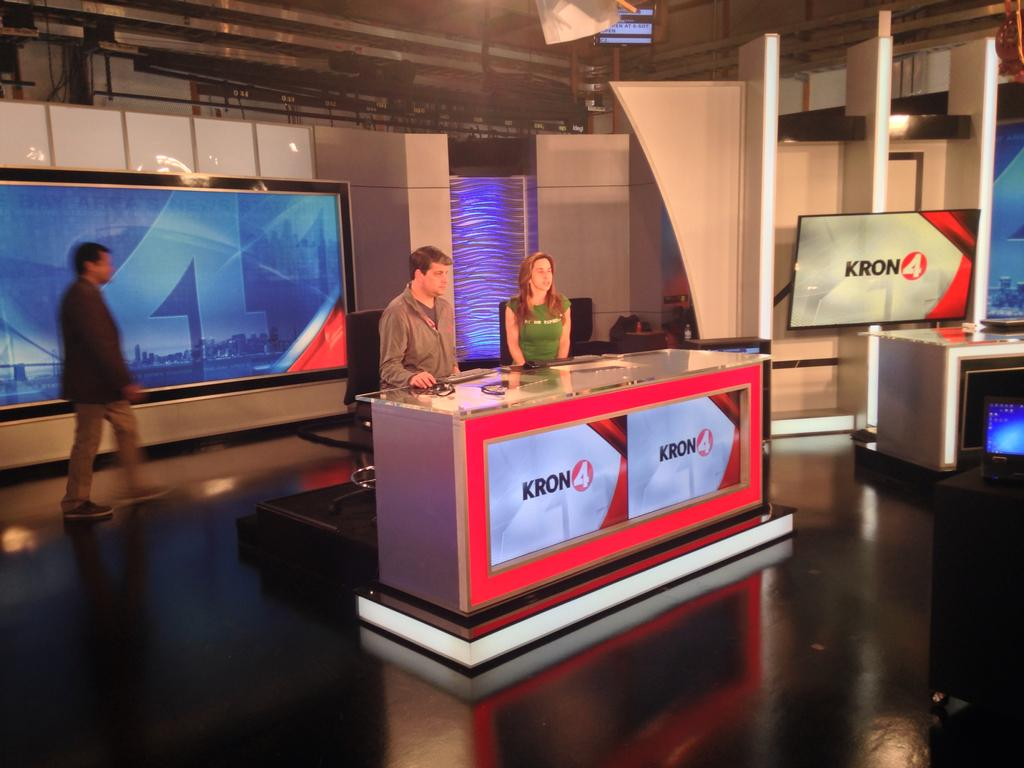<image>
Write a terse but informative summary of the picture. A man and a woman sit behind a news desk for the KRON 4 station. 